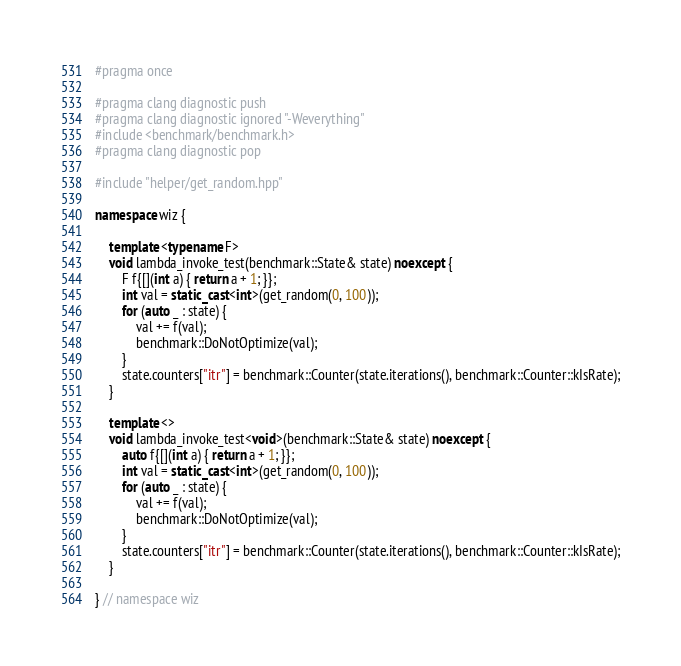<code> <loc_0><loc_0><loc_500><loc_500><_C++_>#pragma once

#pragma clang diagnostic push
#pragma clang diagnostic ignored "-Weverything"
#include <benchmark/benchmark.h>
#pragma clang diagnostic pop

#include "helper/get_random.hpp"

namespace wiz {

    template <typename F>
    void lambda_invoke_test(benchmark::State& state) noexcept {
        F f{[](int a) { return a + 1; }};
        int val = static_cast<int>(get_random(0, 100));
        for (auto _ : state) {
            val += f(val);
            benchmark::DoNotOptimize(val);
        }
        state.counters["itr"] = benchmark::Counter(state.iterations(), benchmark::Counter::kIsRate);
    }

    template <>
    void lambda_invoke_test<void>(benchmark::State& state) noexcept {
        auto f{[](int a) { return a + 1; }};
        int val = static_cast<int>(get_random(0, 100));
        for (auto _ : state) {
            val += f(val);
            benchmark::DoNotOptimize(val);
        }
        state.counters["itr"] = benchmark::Counter(state.iterations(), benchmark::Counter::kIsRate);
    }

} // namespace wiz
</code> 